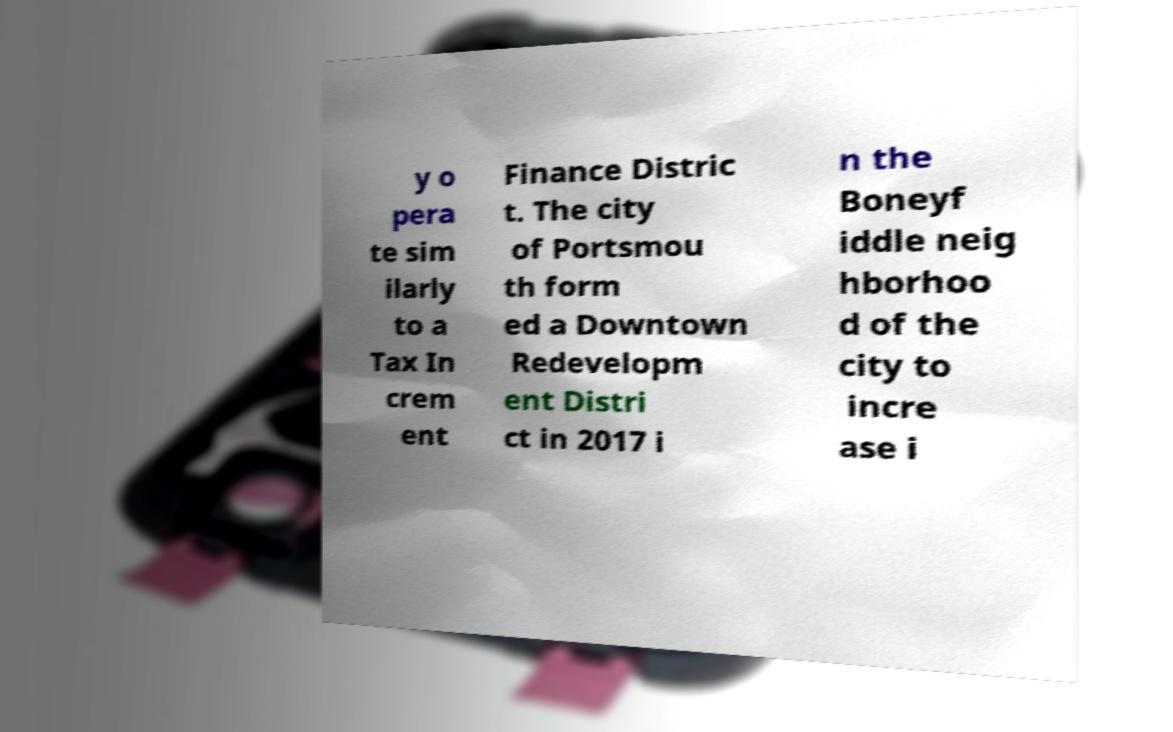For documentation purposes, I need the text within this image transcribed. Could you provide that? y o pera te sim ilarly to a Tax In crem ent Finance Distric t. The city of Portsmou th form ed a Downtown Redevelopm ent Distri ct in 2017 i n the Boneyf iddle neig hborhoo d of the city to incre ase i 